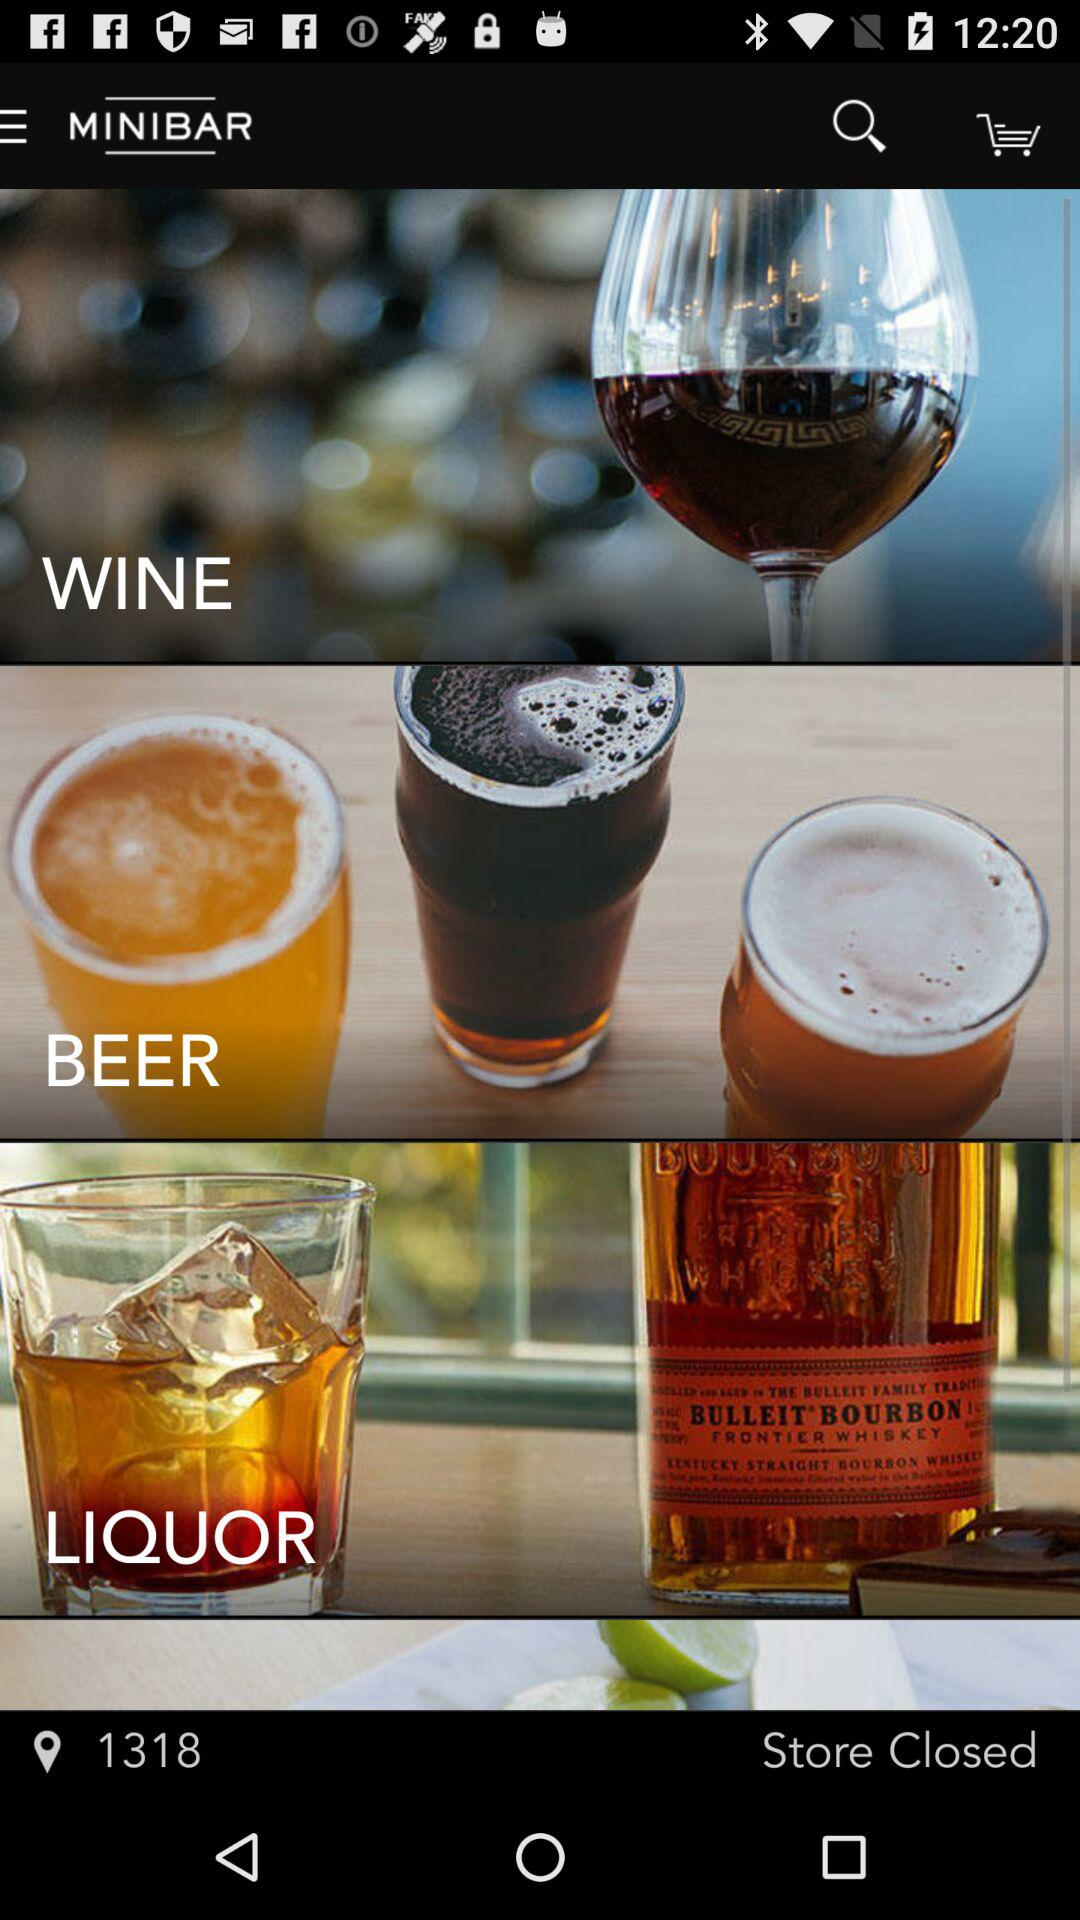Is the store open or closed? The store is "Closed". 